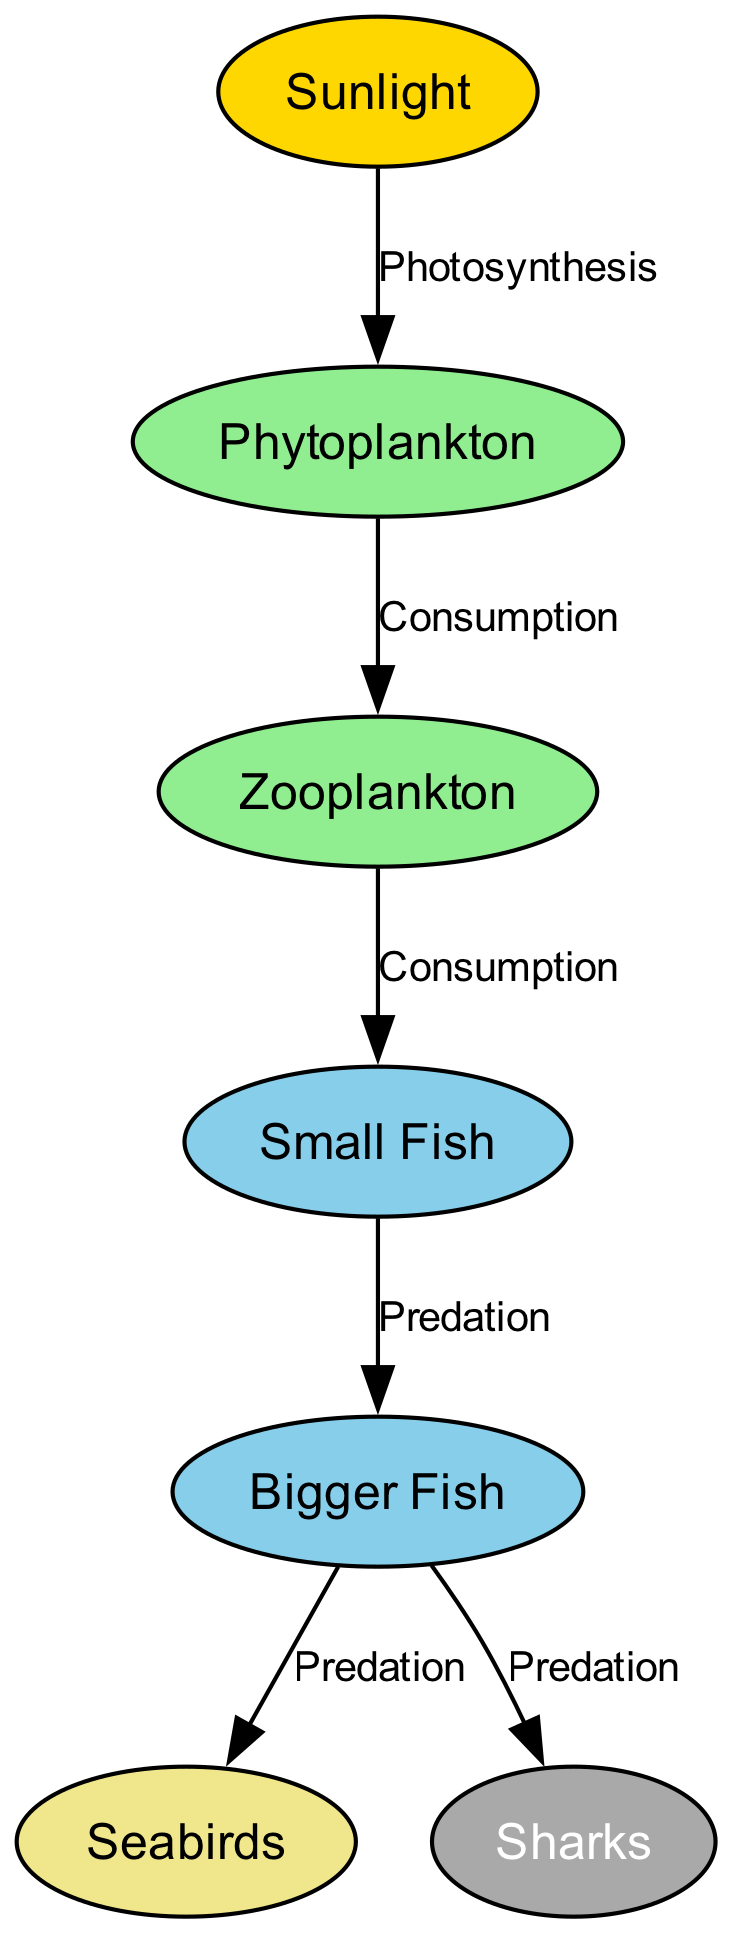What is the primary source of energy in the coastal food chain? The diagram shows that sunlight is the initial node in the food chain, and it is represented as the primary source of energy affecting marine life, specifically phytoplankton, which starts the chain through photosynthesis.
Answer: Sunlight How many nodes are present in the diagram? By counting the distinct entities displayed in the diagram, we can identify the following nodes: sunlight, phytoplankton, zooplankton, small fish, bigger fish, seabirds, and sharks. This results in a total of seven nodes.
Answer: 7 Which organism is at the top of this coastal food chain? The diagram indicates that sharks consume bigger fish, positioning them at the top of the food chain. They are indicated as the last node in the flow.
Answer: Sharks What relationship describes the interaction between phytoplankton and zooplankton? Referring to the diagram's edges, the interaction shows that zooplankton consume phytoplankton, thus the relationship can be described as consumption.
Answer: Consumption How many predatory relationships are present in the diagram? The edges indicate predatory relationships involving: small fish preying on zooplankton, bigger fish predating on small fish, seabirds preying on bigger fish, and sharks preying on bigger fish. Hence, there are three predation relationships specifically denoted.
Answer: 3 What type of relationship exists between sunlight and phytoplankton? The diagram establishes that sunlight impacts phytoplankton through the process of photosynthesis, which is clearly labeled as their method of energy conversion.
Answer: Photosynthesis Which organisms are directly influenced by zooplankton? The diagram illustrates that zooplankton, as consumers, directly influence the population of small fish, making that the only relationship stemming from zooplankton in this food chain context.
Answer: Small Fish What color represents the node for seabirds in the diagram? In the visual depiction, seabirds are characterized using a light yellow color code, which is indicated in the node representation.
Answer: F0E68C 